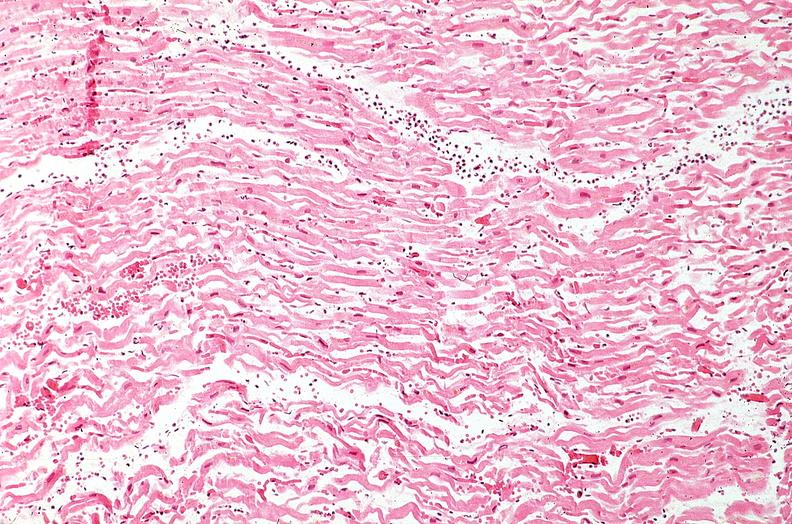s cardiovascular present?
Answer the question using a single word or phrase. Yes 